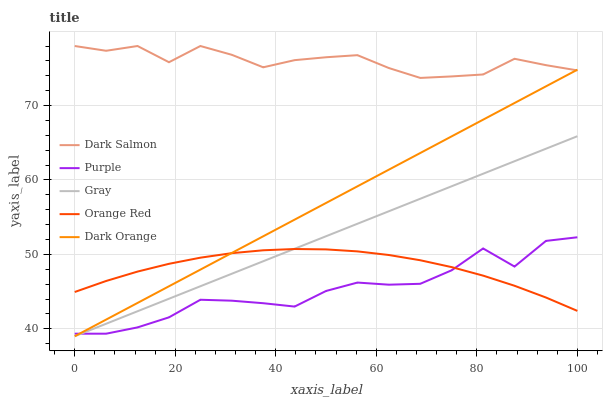Does Purple have the minimum area under the curve?
Answer yes or no. Yes. Does Dark Salmon have the maximum area under the curve?
Answer yes or no. Yes. Does Gray have the minimum area under the curve?
Answer yes or no. No. Does Gray have the maximum area under the curve?
Answer yes or no. No. Is Dark Orange the smoothest?
Answer yes or no. Yes. Is Purple the roughest?
Answer yes or no. Yes. Is Gray the smoothest?
Answer yes or no. No. Is Gray the roughest?
Answer yes or no. No. Does Gray have the lowest value?
Answer yes or no. Yes. Does Dark Salmon have the lowest value?
Answer yes or no. No. Does Dark Salmon have the highest value?
Answer yes or no. Yes. Does Gray have the highest value?
Answer yes or no. No. Is Purple less than Dark Salmon?
Answer yes or no. Yes. Is Dark Salmon greater than Orange Red?
Answer yes or no. Yes. Does Dark Orange intersect Purple?
Answer yes or no. Yes. Is Dark Orange less than Purple?
Answer yes or no. No. Is Dark Orange greater than Purple?
Answer yes or no. No. Does Purple intersect Dark Salmon?
Answer yes or no. No. 